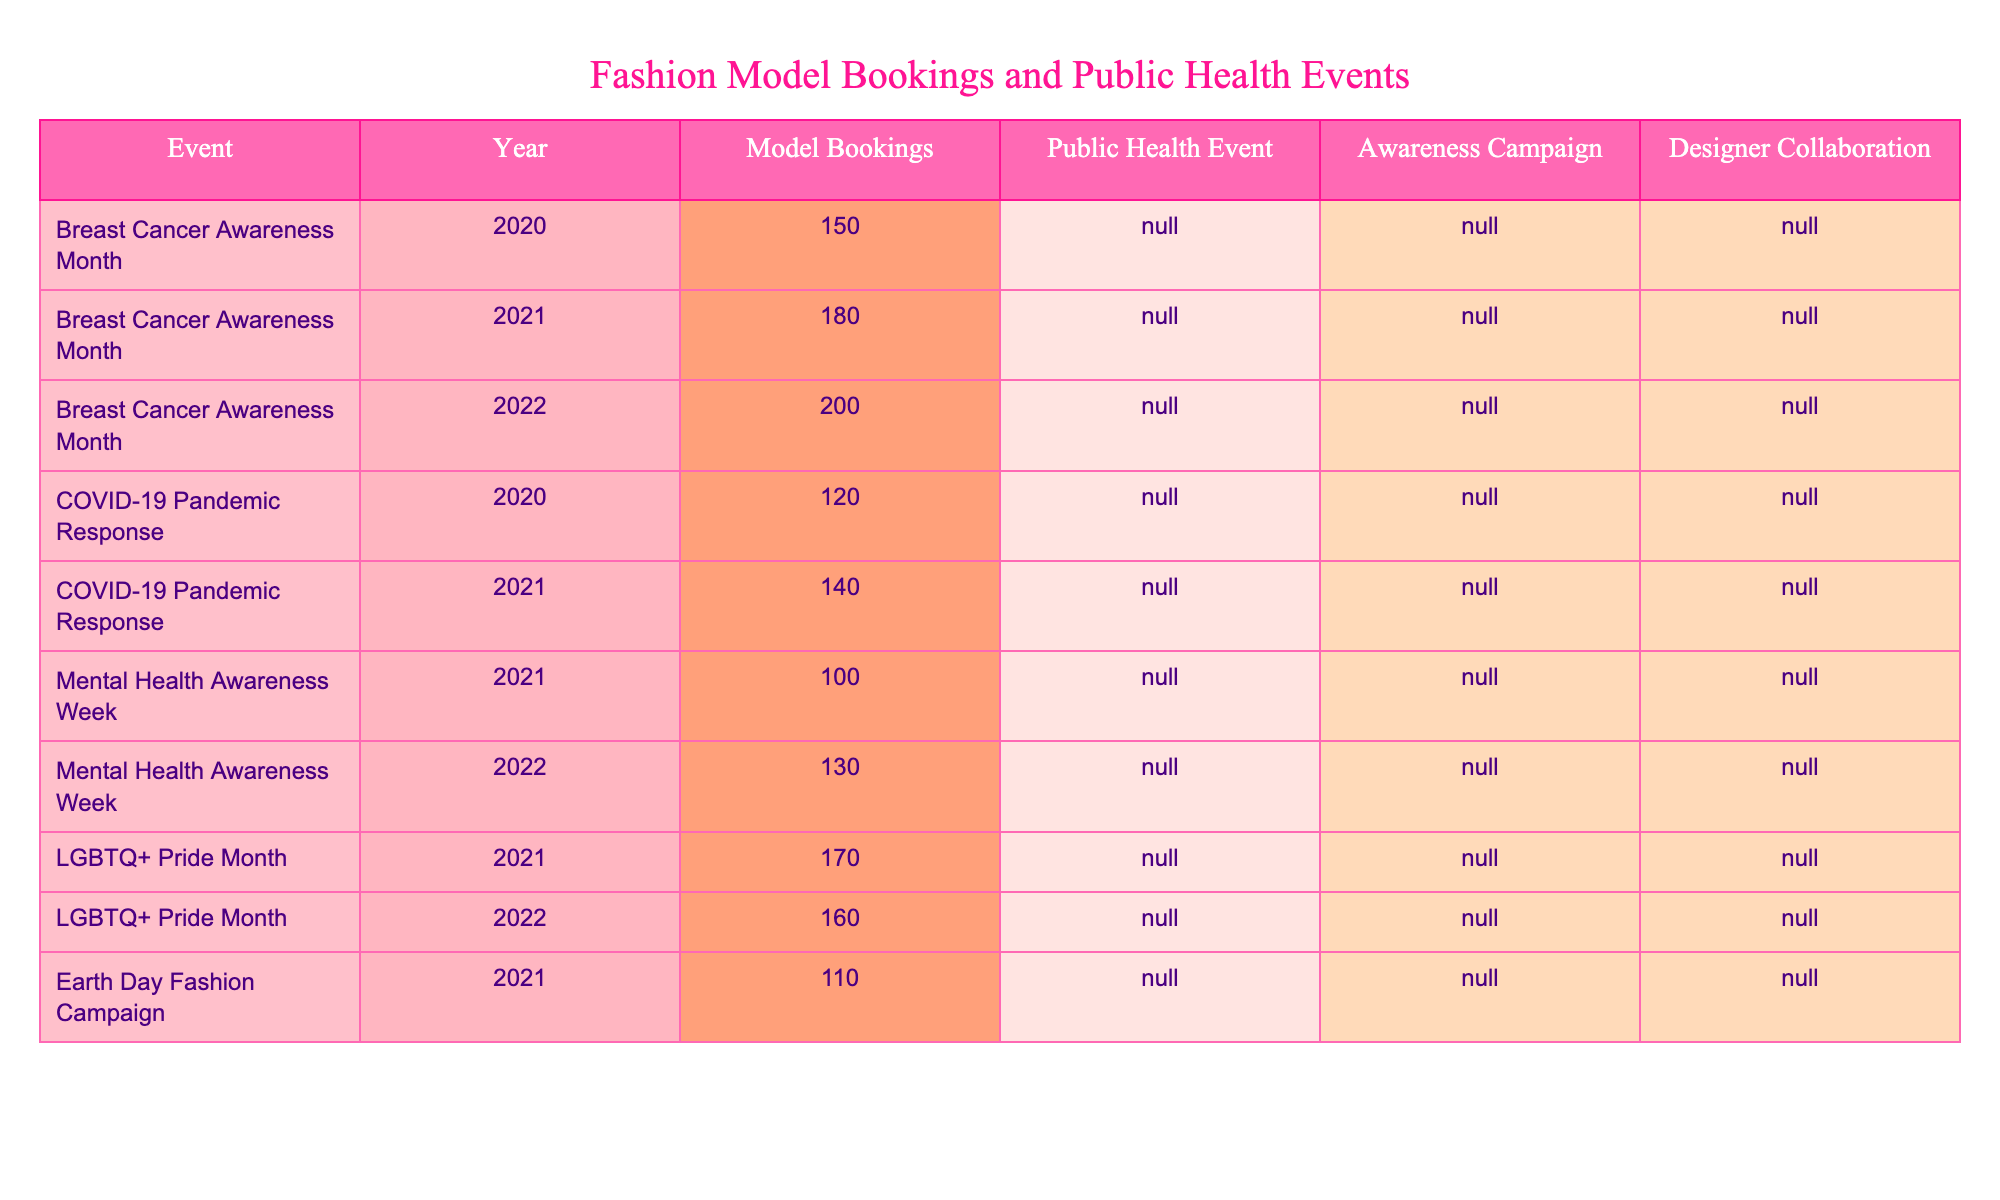What's the total number of model bookings in 2022? In 2022, we can see that the only relevant data points related to model bookings in that year are from the "Breast Cancer Awareness Month" (200 bookings) and "Mental Health Awareness Week" (130 bookings). Therefore, we add these values together: 200 + 130 = 330.
Answer: 330 How many events had public health awareness campaigns in 2021? Referring to the table, we look at the events in 2021. The events with an awareness campaign are "Breast Cancer Awareness Month" (Yes), "Mental Health Awareness Week" (Yes), and "LGBTQ+ Pride Month" (Yes). Thus, there are a total of 3 events.
Answer: 3 What was the highest number of model bookings in a single year? We check the model bookings across all years. The maximum value is from "Breast Cancer Awareness Month" in 2022 with 200 bookings, and no other event has a higher booking count than that.
Answer: 200 Did the number of bookings increase from 2020 to 2021 for the COVID-19 pandemic response? By looking at the table, in 2020, the bookings for the COVID-19 pandemic response are 120, and in 2021 they are 140. Since 140 is greater than 120, we can confirm there was an increase.
Answer: Yes Which public health events had designer collaborations in 2021? Reviewing the table, we focus on the year 2021. The events with designer collaborations are "COVID-19 Pandemic Response" (Yes), "Mental Health Awareness Week" (No), and "LGBTQ+ Pride Month" (Yes). Specifically, there are two events with collaborations.
Answer: 2 Is there a public health event in 2022 that also had an awareness campaign? Looking at the year 2022, the event "Breast Cancer Awareness Month" had both a public health event and an awareness campaign (Yes), while "Mental Health Awareness Week" also had an awareness campaign. Hence, there is at least one event that meets the criteria.
Answer: Yes What is the average number of model bookings during public health events in 2020? We identify the relevant data points for 2020: "Breast Cancer Awareness Month" with 150 bookings and "COVID-19 Pandemic Response" with 120 bookings. Calculating the average: (150 + 120) / 2 = 135.
Answer: 135 How does the number of model bookings for LGBTQ+ Pride Month compare between 2021 and 2022? For 2021, the bookings are 170, and for 2022, they are 160. Comparing the two, 170 is greater than 160, indicating a decline in bookings in 2022 compared to 2021.
Answer: Decreased In which year did "Earth Day Fashion Campaign" occur and how many bookings did it have? Checking the table reveals that the "Earth Day Fashion Campaign" took place in 2021 and it had 110 bookings.
Answer: 2021, 110 